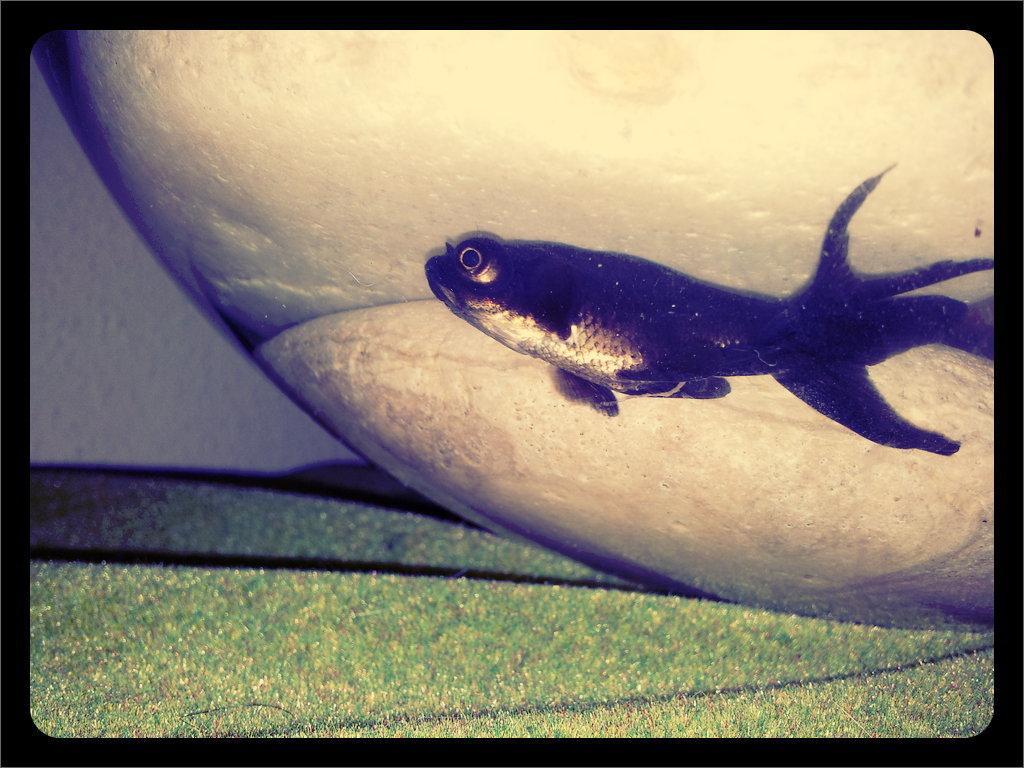How would you summarize this image in a sentence or two? This is an edited image it has borders at the four sides. In the center of the image there is a fish. 